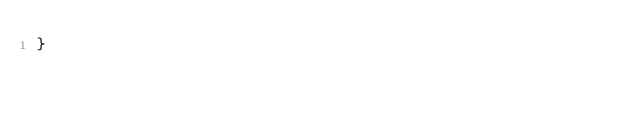Convert code to text. <code><loc_0><loc_0><loc_500><loc_500><_CSS_>}
</code> 